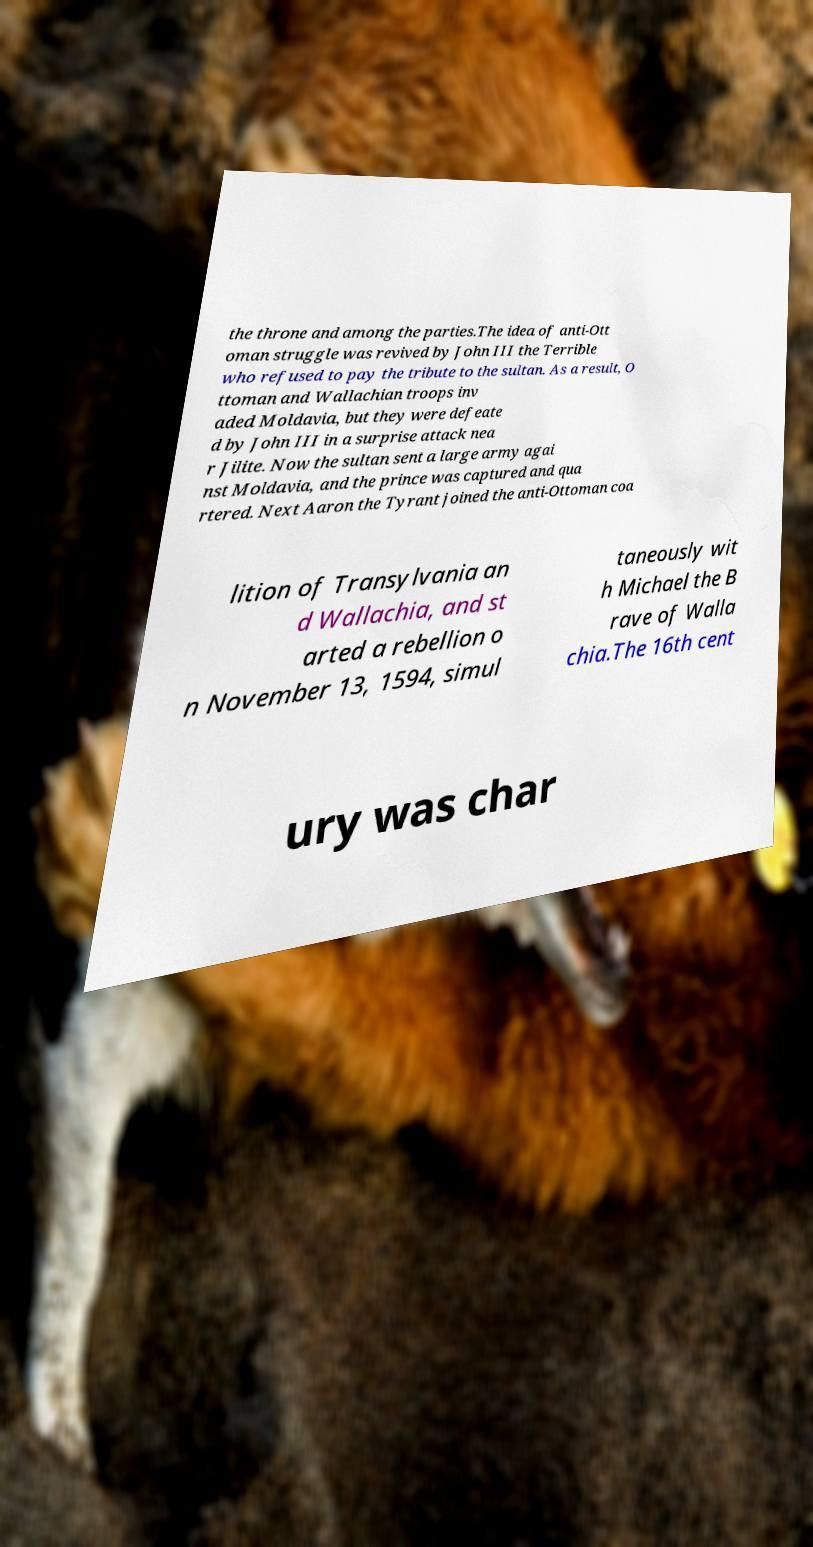Please identify and transcribe the text found in this image. the throne and among the parties.The idea of anti-Ott oman struggle was revived by John III the Terrible who refused to pay the tribute to the sultan. As a result, O ttoman and Wallachian troops inv aded Moldavia, but they were defeate d by John III in a surprise attack nea r Jilite. Now the sultan sent a large army agai nst Moldavia, and the prince was captured and qua rtered. Next Aaron the Tyrant joined the anti-Ottoman coa lition of Transylvania an d Wallachia, and st arted a rebellion o n November 13, 1594, simul taneously wit h Michael the B rave of Walla chia.The 16th cent ury was char 